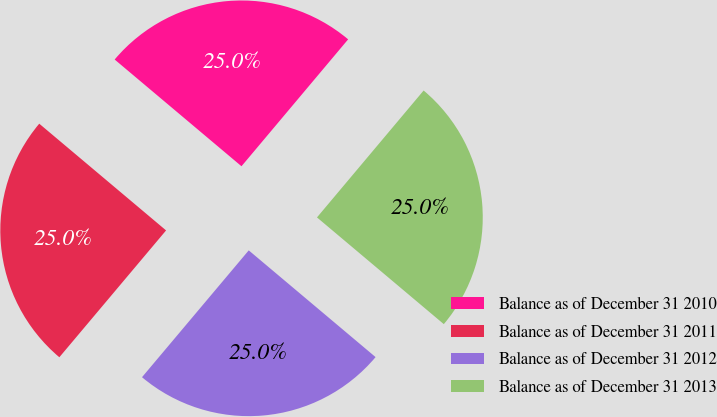Convert chart to OTSL. <chart><loc_0><loc_0><loc_500><loc_500><pie_chart><fcel>Balance as of December 31 2010<fcel>Balance as of December 31 2011<fcel>Balance as of December 31 2012<fcel>Balance as of December 31 2013<nl><fcel>24.99%<fcel>25.0%<fcel>25.0%<fcel>25.01%<nl></chart> 